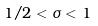Convert formula to latex. <formula><loc_0><loc_0><loc_500><loc_500>1 / 2 < \sigma < 1</formula> 